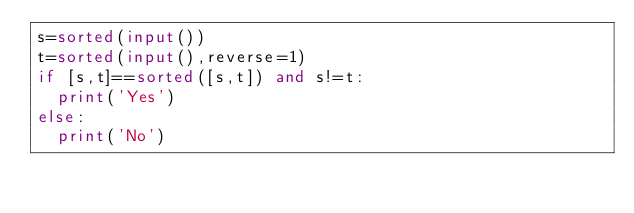Convert code to text. <code><loc_0><loc_0><loc_500><loc_500><_Python_>s=sorted(input())
t=sorted(input(),reverse=1)
if [s,t]==sorted([s,t]) and s!=t:
  print('Yes')
else:
  print('No')</code> 